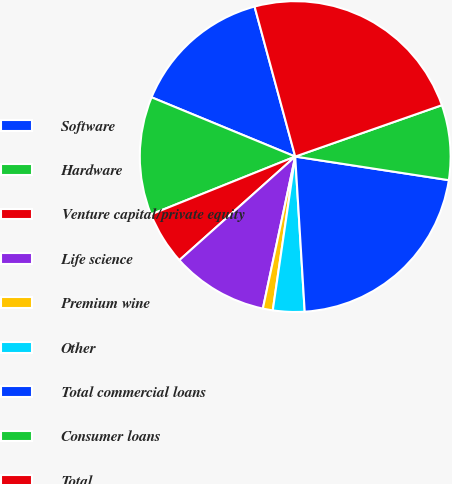Convert chart. <chart><loc_0><loc_0><loc_500><loc_500><pie_chart><fcel>Software<fcel>Hardware<fcel>Venture capital/private equity<fcel>Life science<fcel>Premium wine<fcel>Other<fcel>Total commercial loans<fcel>Consumer loans<fcel>Total<nl><fcel>14.56%<fcel>12.3%<fcel>5.54%<fcel>10.05%<fcel>1.03%<fcel>3.28%<fcel>21.6%<fcel>7.79%<fcel>23.85%<nl></chart> 